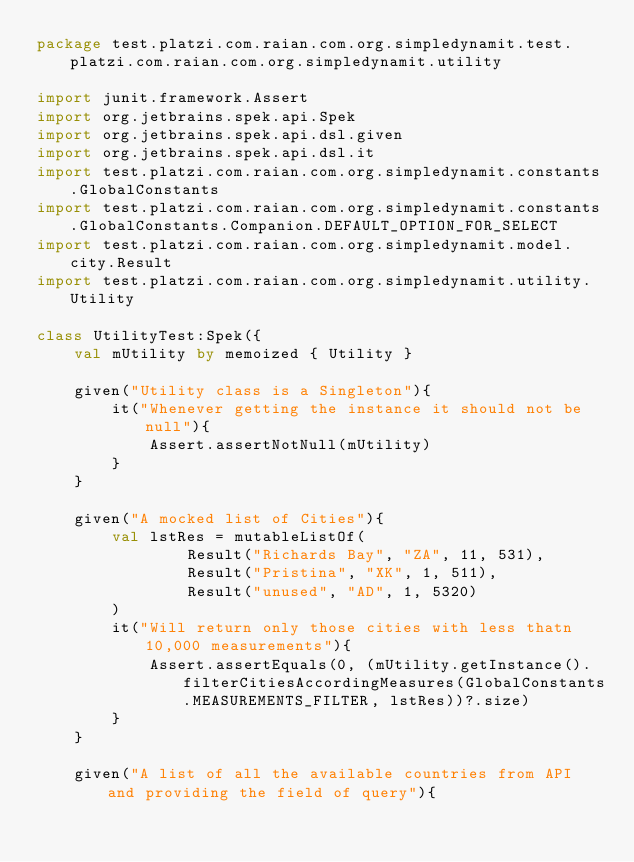Convert code to text. <code><loc_0><loc_0><loc_500><loc_500><_Kotlin_>package test.platzi.com.raian.com.org.simpledynamit.test.platzi.com.raian.com.org.simpledynamit.utility

import junit.framework.Assert
import org.jetbrains.spek.api.Spek
import org.jetbrains.spek.api.dsl.given
import org.jetbrains.spek.api.dsl.it
import test.platzi.com.raian.com.org.simpledynamit.constants.GlobalConstants
import test.platzi.com.raian.com.org.simpledynamit.constants.GlobalConstants.Companion.DEFAULT_OPTION_FOR_SELECT
import test.platzi.com.raian.com.org.simpledynamit.model.city.Result
import test.platzi.com.raian.com.org.simpledynamit.utility.Utility

class UtilityTest:Spek({
    val mUtility by memoized { Utility }

    given("Utility class is a Singleton"){
        it("Whenever getting the instance it should not be null"){
            Assert.assertNotNull(mUtility)
        }
    }

    given("A mocked list of Cities"){
        val lstRes = mutableListOf(
                Result("Richards Bay", "ZA", 11, 531),
                Result("Pristina", "XK", 1, 511),
                Result("unused", "AD", 1, 5320)
        )
        it("Will return only those cities with less thatn 10,000 measurements"){
            Assert.assertEquals(0, (mUtility.getInstance().filterCitiesAccordingMeasures(GlobalConstants.MEASUREMENTS_FILTER, lstRes))?.size)
        }
    }

    given("A list of all the available countries from API and providing the field of query"){</code> 